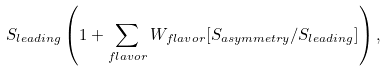<formula> <loc_0><loc_0><loc_500><loc_500>S _ { l e a d i n g } \left ( 1 + \sum _ { f l a v o r } W _ { f l a v o r } [ S _ { a s y m m e t r y } / S _ { l e a d i n g } ] \right ) ,</formula> 